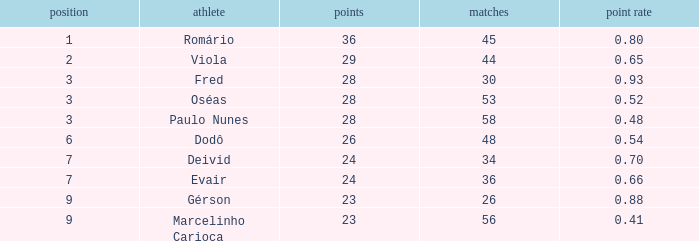How many games have 23 goals with a rank greater than 9? 0.0. 